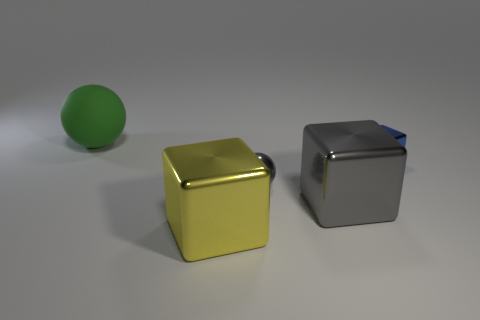Add 4 cyan rubber cubes. How many objects exist? 9 Subtract all balls. How many objects are left? 3 Subtract all gray things. Subtract all large green matte things. How many objects are left? 2 Add 2 big green matte balls. How many big green matte balls are left? 3 Add 1 tiny gray metallic objects. How many tiny gray metallic objects exist? 2 Subtract 1 green balls. How many objects are left? 4 